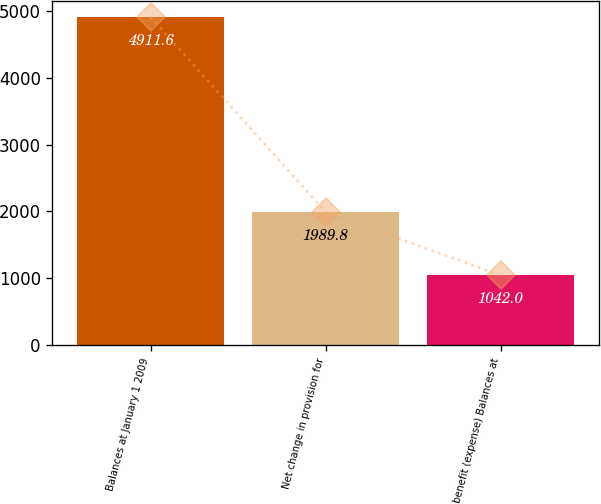Convert chart to OTSL. <chart><loc_0><loc_0><loc_500><loc_500><bar_chart><fcel>Balances at January 1 2009<fcel>Net change in provision for<fcel>benefit (expense) Balances at<nl><fcel>4911.6<fcel>1989.8<fcel>1042<nl></chart> 